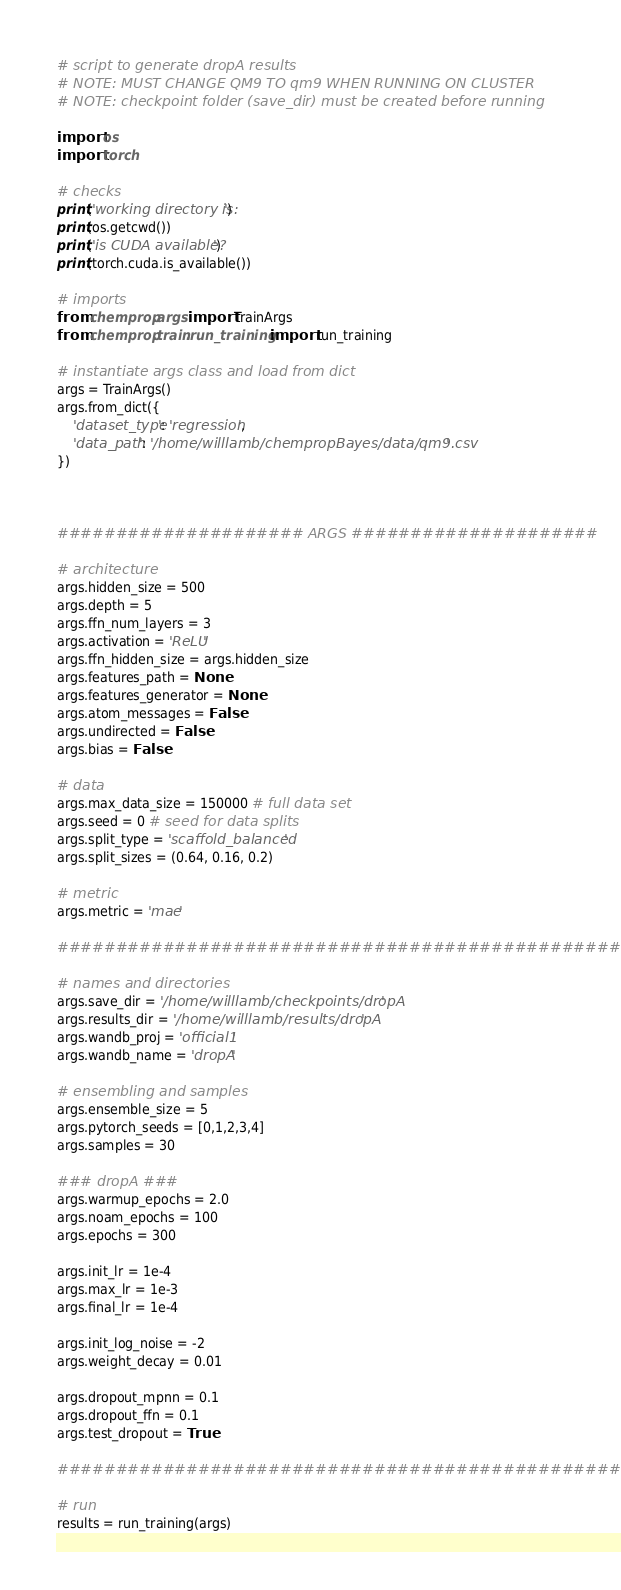Convert code to text. <code><loc_0><loc_0><loc_500><loc_500><_Python_># script to generate dropA results
# NOTE: MUST CHANGE QM9 TO qm9 WHEN RUNNING ON CLUSTER
# NOTE: checkpoint folder (save_dir) must be created before running

import os
import torch

# checks
print('working directory is:')
print(os.getcwd())
print('is CUDA available?')
print(torch.cuda.is_available())

# imports
from chemprop.args import TrainArgs
from chemprop.train.run_training import run_training

# instantiate args class and load from dict
args = TrainArgs()
args.from_dict({
    'dataset_type': 'regression',
    'data_path': '/home/willlamb/chempropBayes/data/qm9.csv'
})



##################### ARGS #####################

# architecture
args.hidden_size = 500
args.depth = 5
args.ffn_num_layers = 3
args.activation = 'ReLU'
args.ffn_hidden_size = args.hidden_size
args.features_path = None
args.features_generator = None
args.atom_messages = False
args.undirected = False
args.bias = False

# data
args.max_data_size = 150000 # full data set
args.seed = 0 # seed for data splits
args.split_type = 'scaffold_balanced'
args.split_sizes = (0.64, 0.16, 0.2)

# metric
args.metric = 'mae'

################################################

# names and directories
args.save_dir = '/home/willlamb/checkpoints/dropA'
args.results_dir = '/home/willlamb/results/dropA'
args.wandb_proj = 'official1'
args.wandb_name = 'dropA'

# ensembling and samples
args.ensemble_size = 5
args.pytorch_seeds = [0,1,2,3,4]
args.samples = 30

### dropA ###
args.warmup_epochs = 2.0
args.noam_epochs = 100
args.epochs = 300

args.init_lr = 1e-4
args.max_lr = 1e-3
args.final_lr = 1e-4

args.init_log_noise = -2
args.weight_decay = 0.01

args.dropout_mpnn = 0.1
args.dropout_ffn = 0.1
args.test_dropout = True  

################################################

# run
results = run_training(args)</code> 